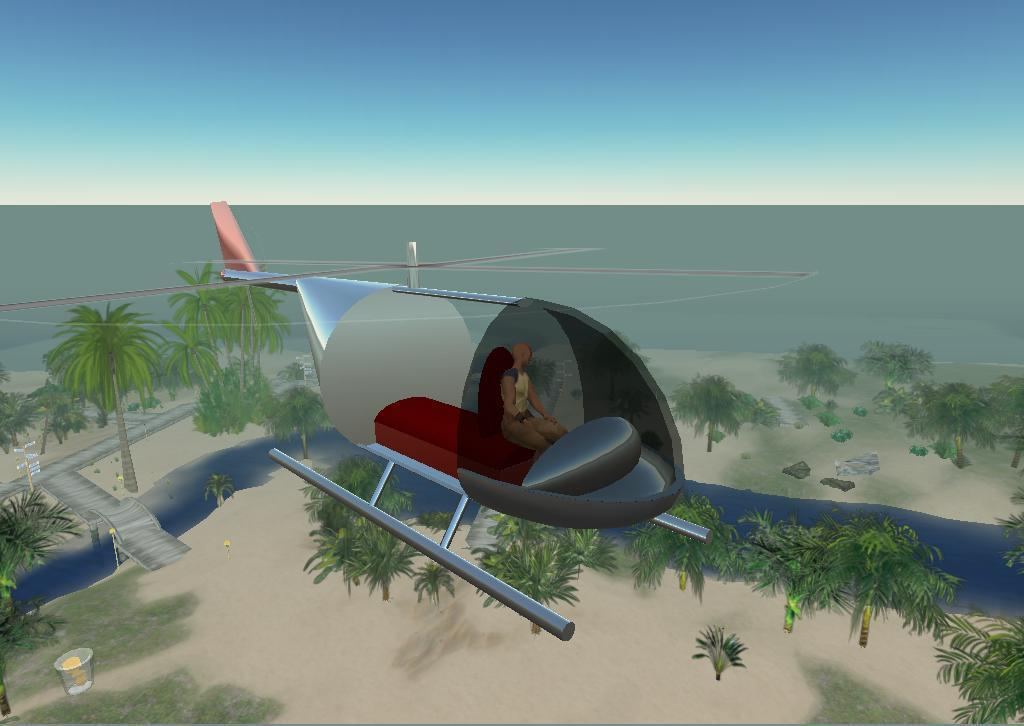What is the main subject in the center of the image? There is a helicopter in the center of the image. Can you describe the helicopter's occupant? There is a person in the helicopter. What type of landscape is visible at the bottom of the image? There are trees and a sea at the bottom of the image. What is visible at the top of the image? The sky is visible at the top of the image. What type of dolls can be seen expanding their channel in the image? There are no dolls or channels present in the image; it features a helicopter with a person inside. 